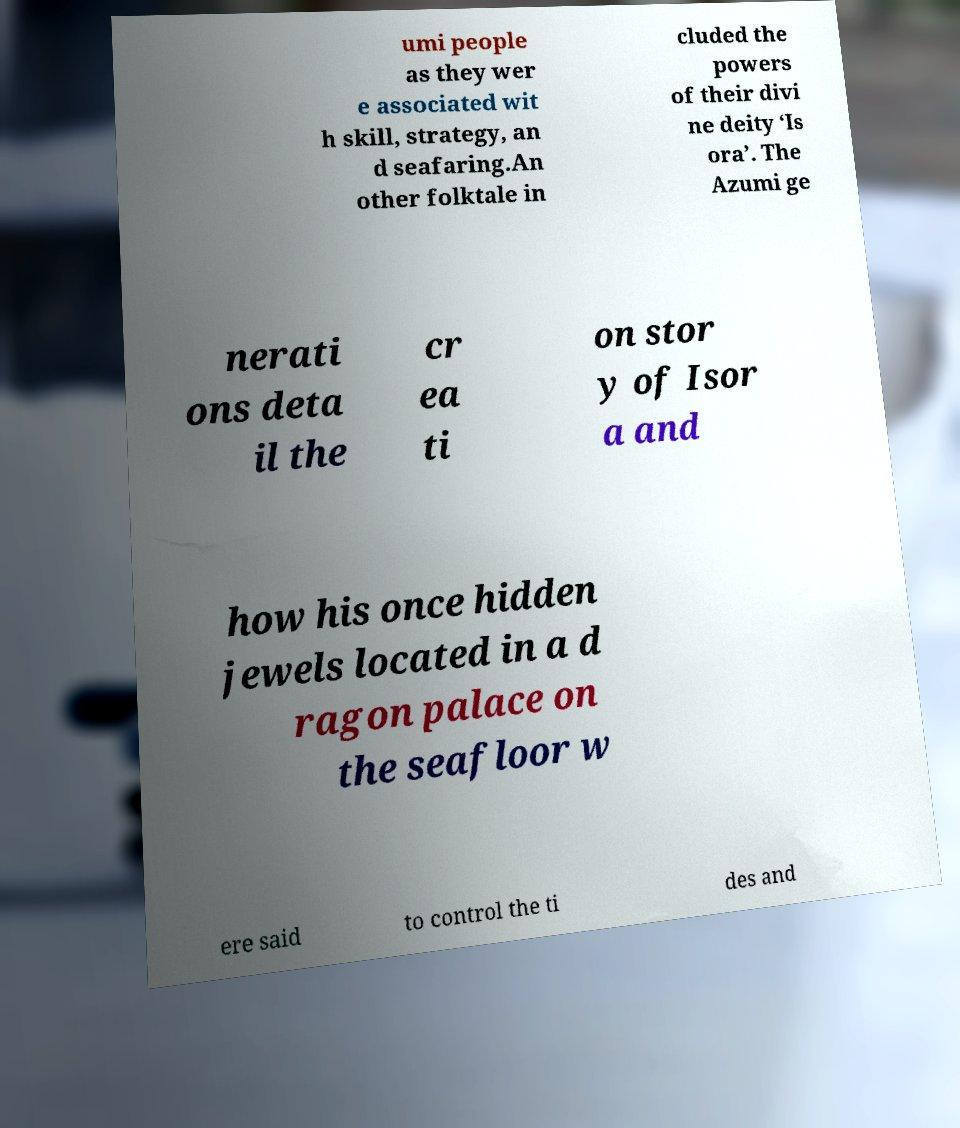Please identify and transcribe the text found in this image. umi people as they wer e associated wit h skill, strategy, an d seafaring.An other folktale in cluded the powers of their divi ne deity ‘Is ora’. The Azumi ge nerati ons deta il the cr ea ti on stor y of Isor a and how his once hidden jewels located in a d ragon palace on the seafloor w ere said to control the ti des and 